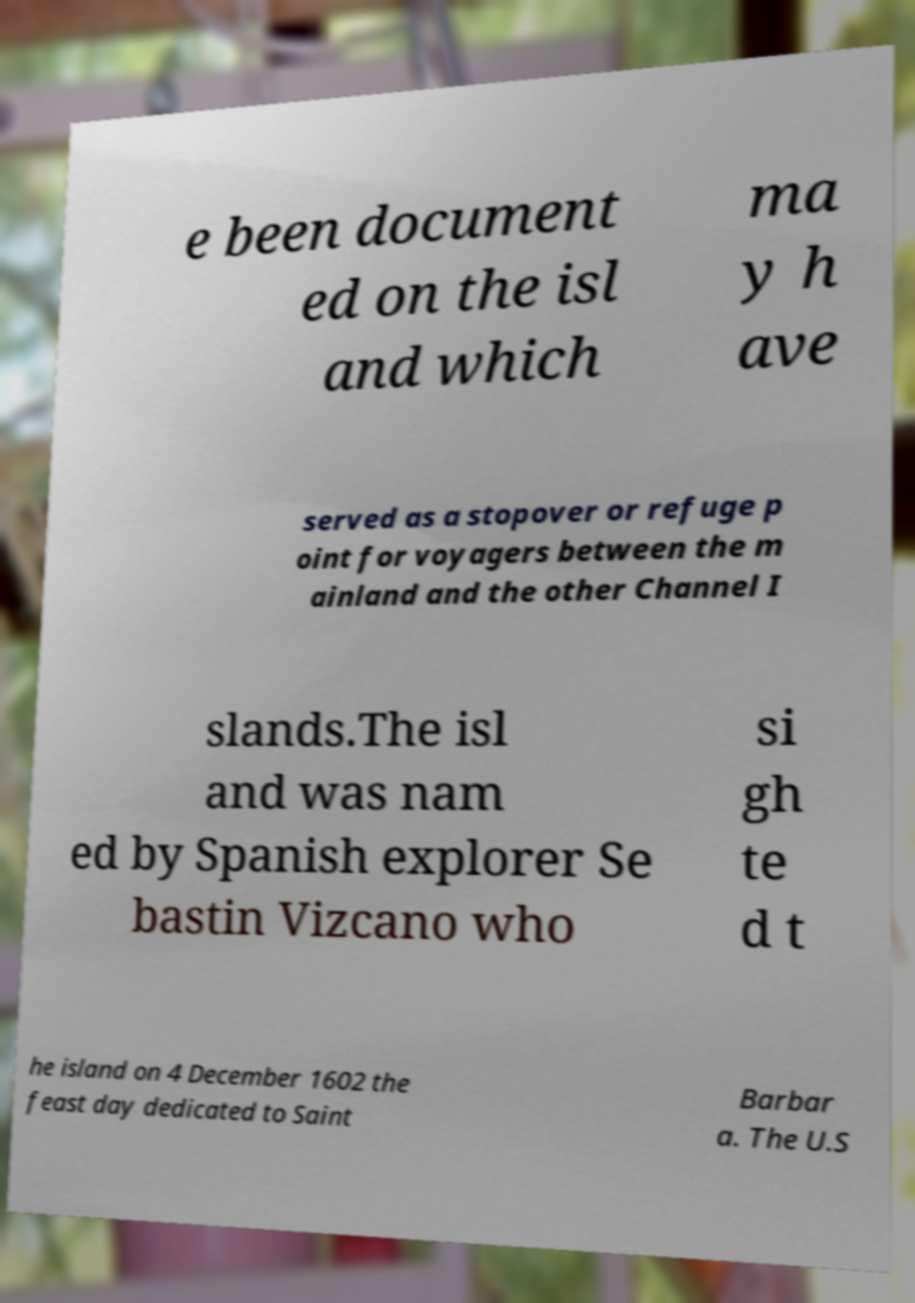Can you read and provide the text displayed in the image?This photo seems to have some interesting text. Can you extract and type it out for me? e been document ed on the isl and which ma y h ave served as a stopover or refuge p oint for voyagers between the m ainland and the other Channel I slands.The isl and was nam ed by Spanish explorer Se bastin Vizcano who si gh te d t he island on 4 December 1602 the feast day dedicated to Saint Barbar a. The U.S 